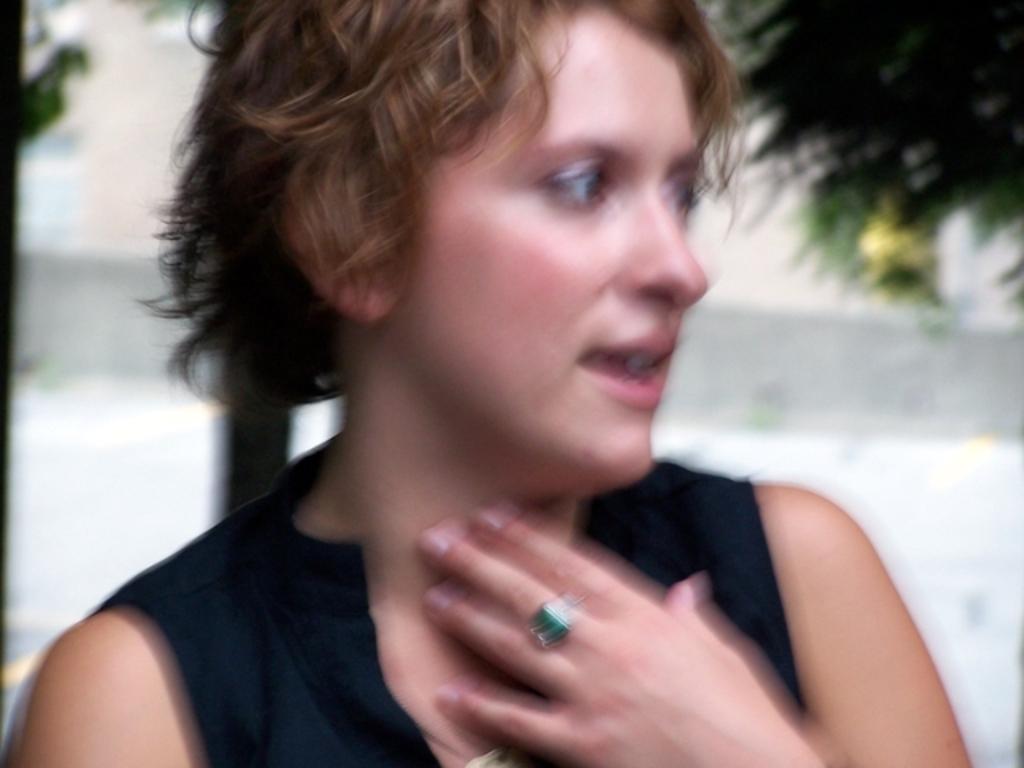Can you describe this image briefly? It is a blur picture, there is a woman in the foreground. 